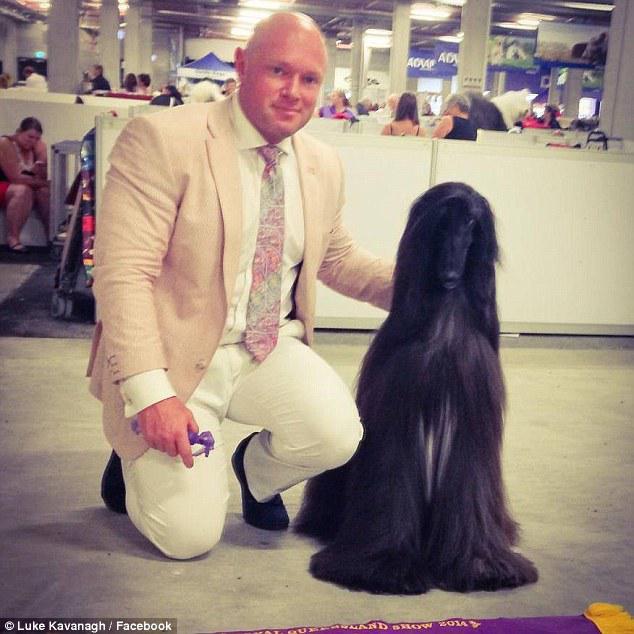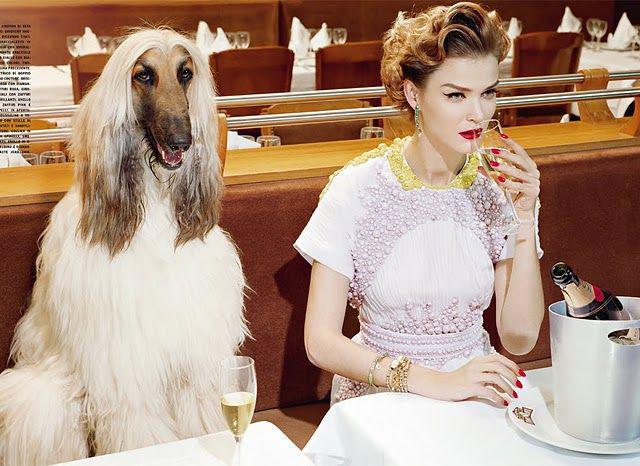The first image is the image on the left, the second image is the image on the right. Analyze the images presented: Is the assertion "There are four dogs in total." valid? Answer yes or no. No. 